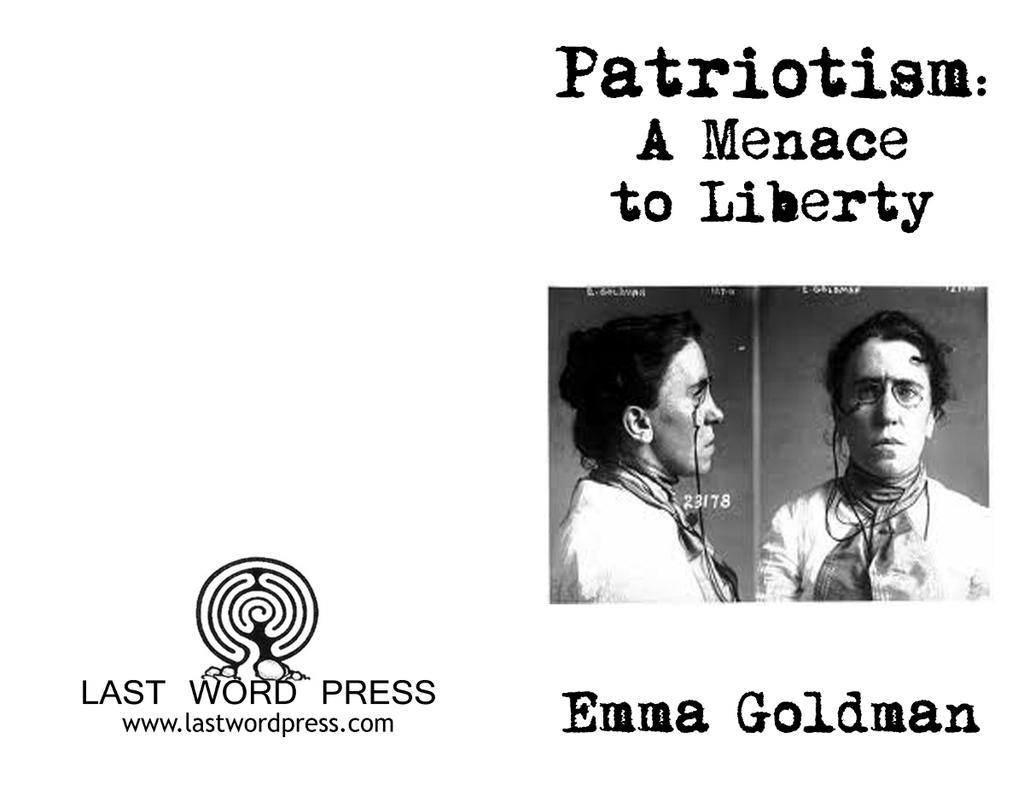Could you give a brief overview of what you see in this image? In this image we can see a poster. On the left side of the image we can see some text and a logo. On the right side of the image we can see two pictures and some text was written. 